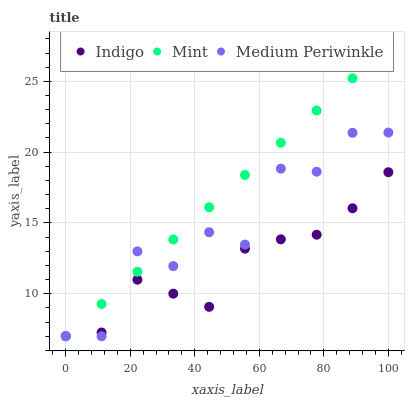Does Indigo have the minimum area under the curve?
Answer yes or no. Yes. Does Mint have the maximum area under the curve?
Answer yes or no. Yes. Does Medium Periwinkle have the minimum area under the curve?
Answer yes or no. No. Does Medium Periwinkle have the maximum area under the curve?
Answer yes or no. No. Is Mint the smoothest?
Answer yes or no. Yes. Is Medium Periwinkle the roughest?
Answer yes or no. Yes. Is Indigo the smoothest?
Answer yes or no. No. Is Indigo the roughest?
Answer yes or no. No. Does Mint have the lowest value?
Answer yes or no. Yes. Does Mint have the highest value?
Answer yes or no. Yes. Does Medium Periwinkle have the highest value?
Answer yes or no. No. Does Indigo intersect Medium Periwinkle?
Answer yes or no. Yes. Is Indigo less than Medium Periwinkle?
Answer yes or no. No. Is Indigo greater than Medium Periwinkle?
Answer yes or no. No. 